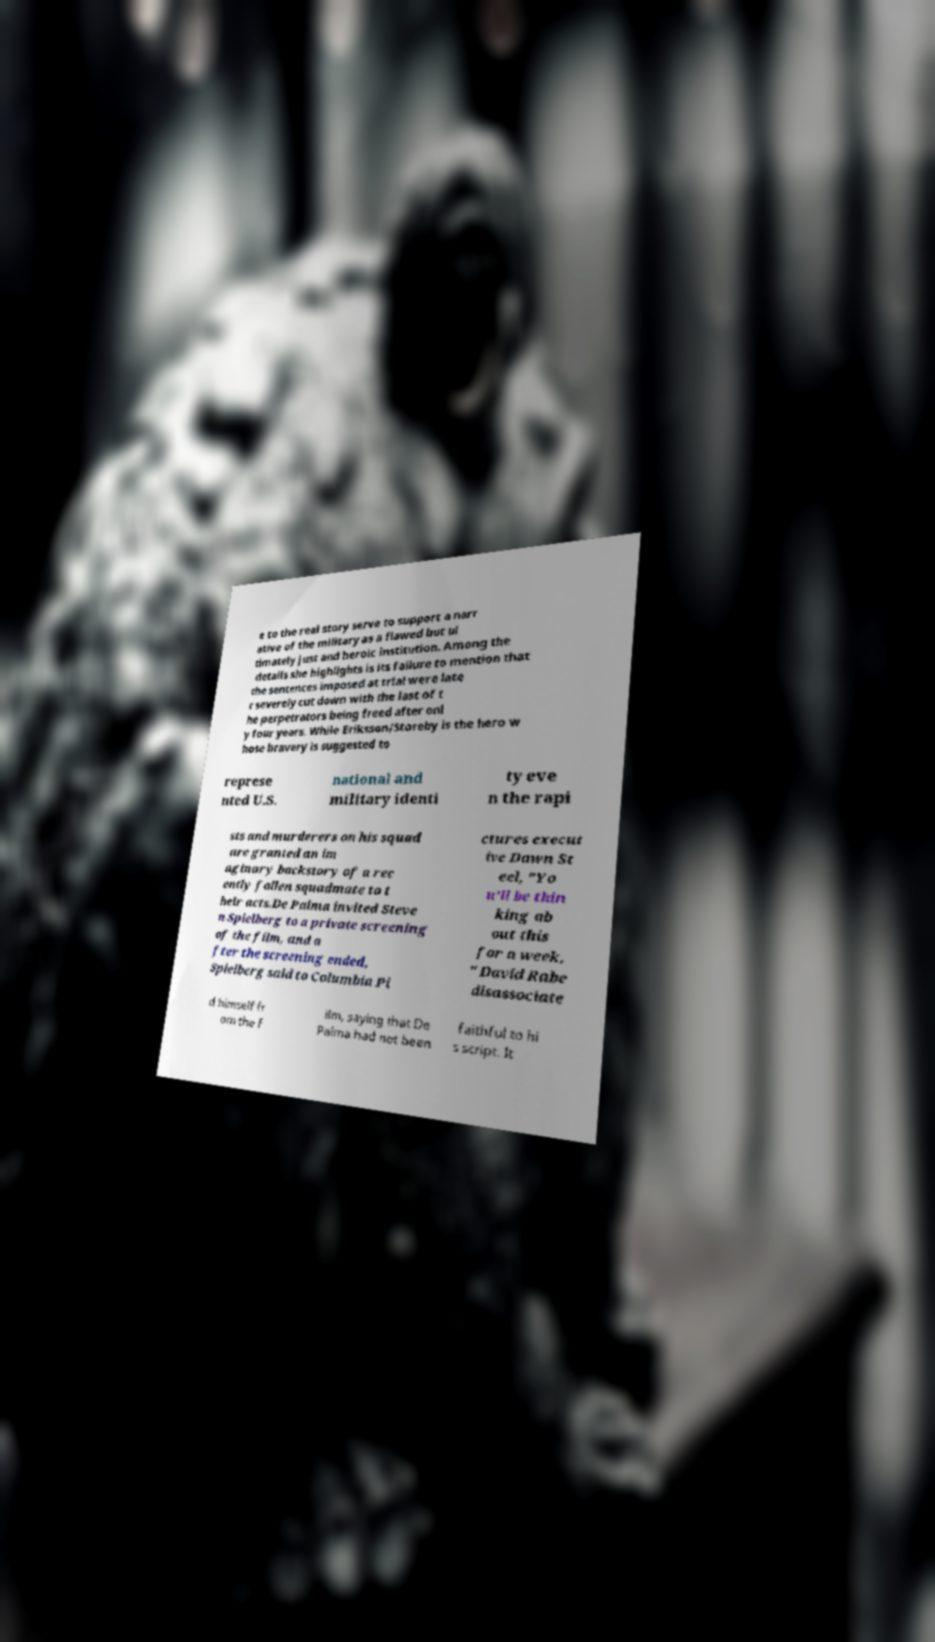Can you accurately transcribe the text from the provided image for me? e to the real story serve to support a narr ative of the military as a flawed but ul timately just and heroic institution. Among the details she highlights is its failure to mention that the sentences imposed at trial were late r severely cut down with the last of t he perpetrators being freed after onl y four years. While Eriksson/Storeby is the hero w hose bravery is suggested to represe nted U.S. national and military identi ty eve n the rapi sts and murderers on his squad are granted an im aginary backstory of a rec ently fallen squadmate to t heir acts.De Palma invited Steve n Spielberg to a private screening of the film, and a fter the screening ended, Spielberg said to Columbia Pi ctures execut ive Dawn St eel, "Yo u'll be thin king ab out this for a week. " David Rabe disassociate d himself fr om the f ilm, saying that De Palma had not been faithful to hi s script. It 